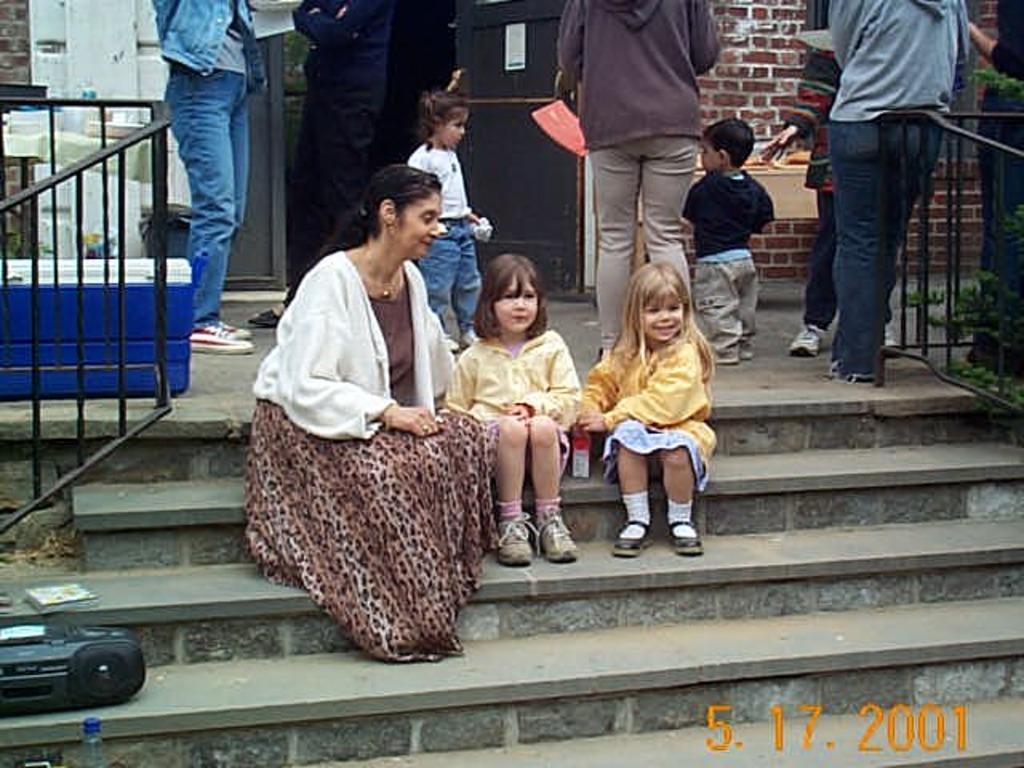Could you give a brief overview of what you see in this image? In this image, we can see people and some are sitting on the stairs. In the background, there are railings and we can see a box, plants, boards and there is a wall. At the bottom, there is some text and we can see a radio, bottle and a book. 